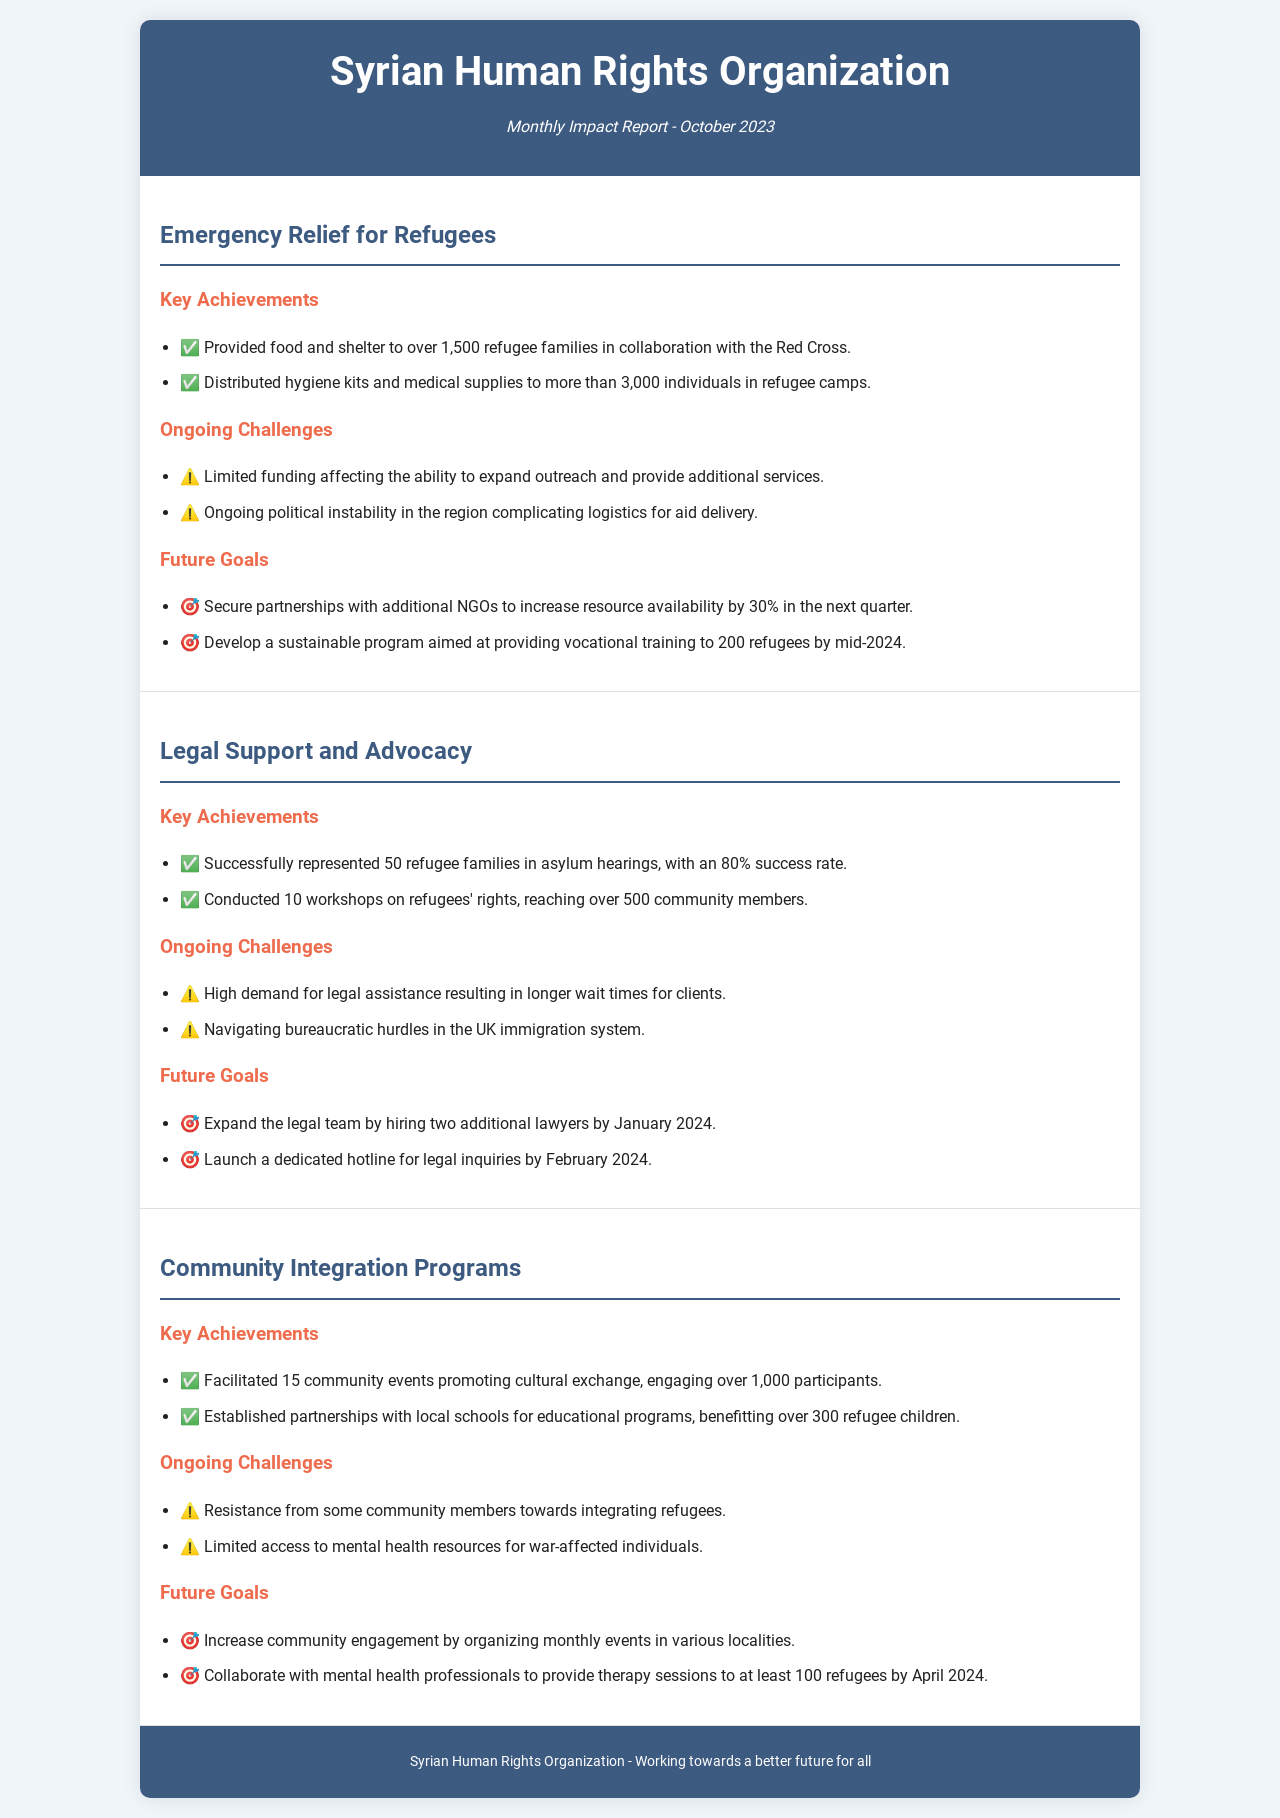What is the reporting period of the report? The reporting period is mentioned in the header of the document.
Answer: October 2023 How many refugee families received food and shelter? This information is provided under the key achievements for the Emergency Relief for Refugees project.
Answer: 1,500 What is the success rate for asylum hearings? This success rate is included in the key achievements for the Legal Support and Advocacy project.
Answer: 80% How many community events did the organization facilitate? This is stated in the achievements of the Community Integration Programs section.
Answer: 15 What is one of the future goals for the Emergency Relief for Refugees project? The future goals section outlines the aim to secure partnerships and develop training programs.
Answer: Secure partnerships with additional NGOs What are the ongoing challenges for the Community Integration Programs? This section lists the challenges the project faces, which include community resistance and mental health access.
Answer: Resistance from some community members How many workshops on refugees' rights were conducted? This information is provided in the key achievements of the Legal Support and Advocacy project.
Answer: 10 What is the goal for therapy sessions in the Community Integration Programs? This goal is specified under the future goals for the Community Integration Programs.
Answer: 100 refugees by April 2024 How many additional lawyers does the Legal Support and Advocacy project intend to hire? This detail is mentioned in the future goals section for the Legal Support and Advocacy project.
Answer: Two 